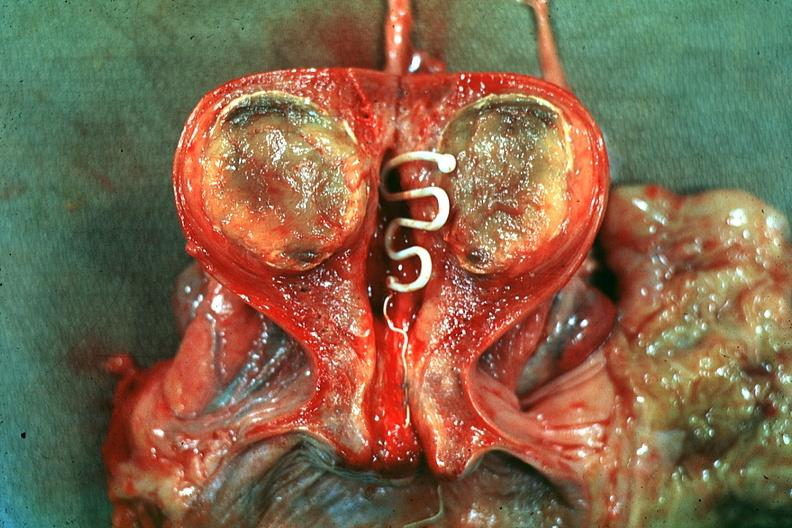s palmar crease normal present?
Answer the question using a single word or phrase. No 